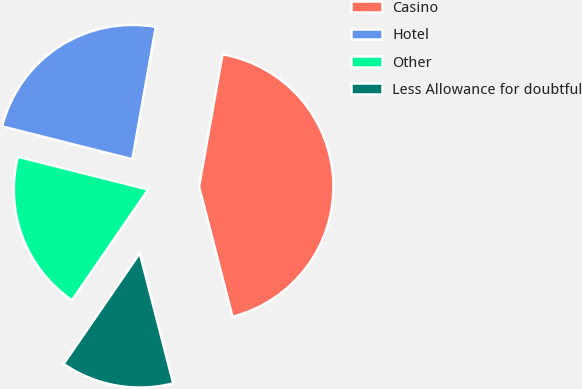Convert chart to OTSL. <chart><loc_0><loc_0><loc_500><loc_500><pie_chart><fcel>Casino<fcel>Hotel<fcel>Other<fcel>Less Allowance for doubtful<nl><fcel>43.2%<fcel>23.86%<fcel>19.34%<fcel>13.6%<nl></chart> 